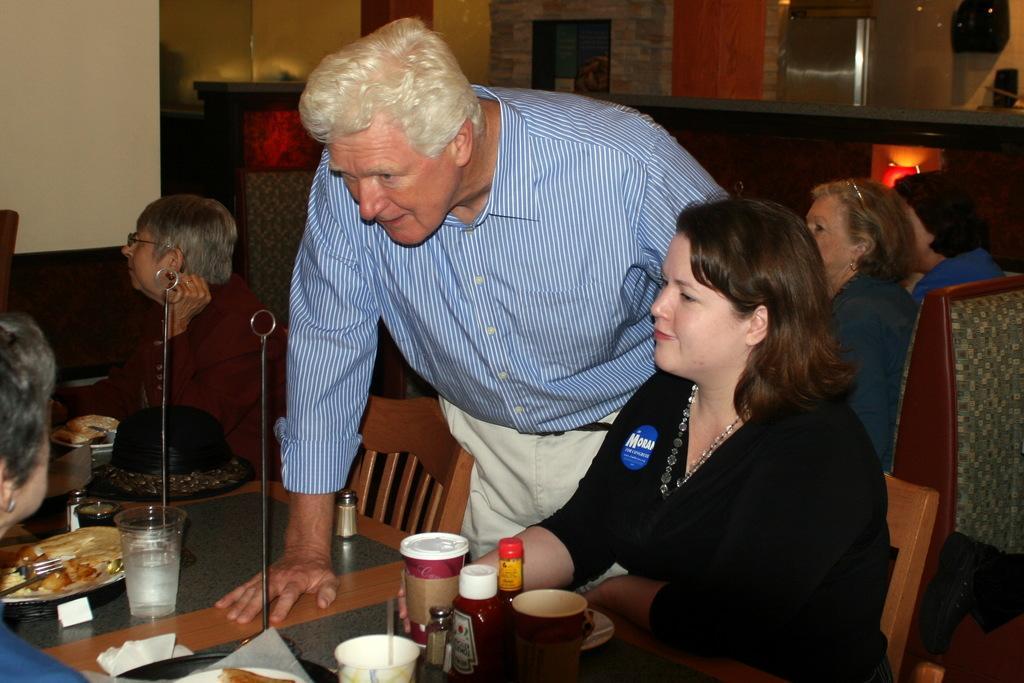In one or two sentences, can you explain what this image depicts? The picture is clicked in a restaurant. On the left side of the picture there is a table, on the table there are glasses, cups, plates, spoons, food items, that, tissues and many objects. On the left there is a person in a blue dress. In the center of the picture there are chairs, in the cars there are two women sitting. In the center of the picture is a man standing. On the right, there are people sitting in chairs. In the background it is a wall, there are light to the wall. 